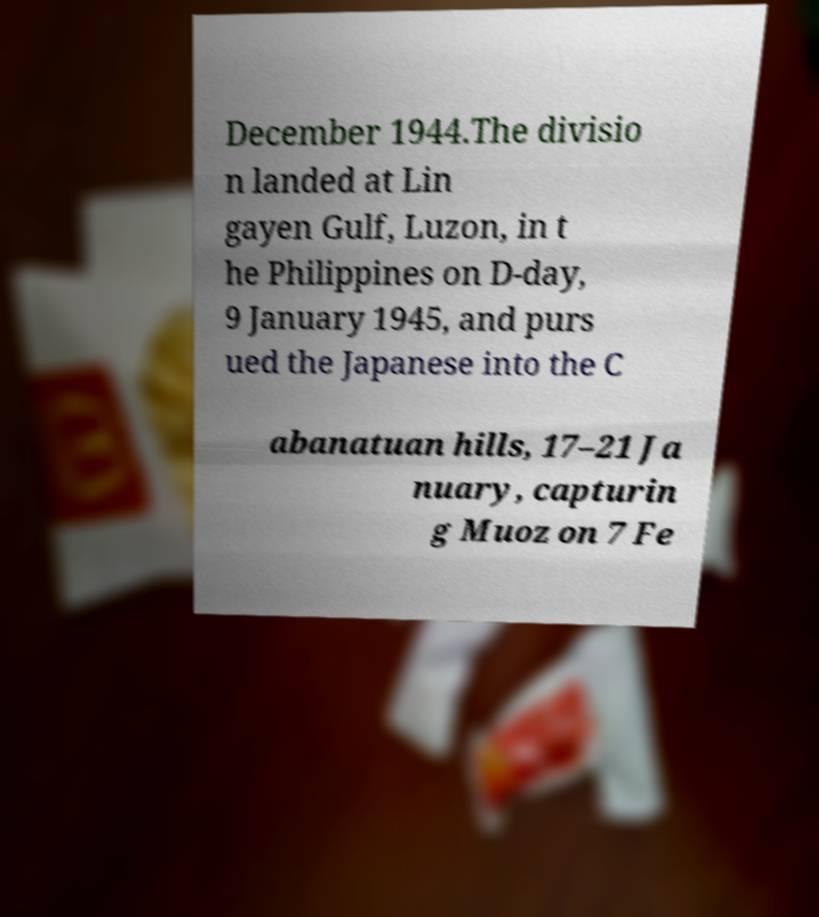For documentation purposes, I need the text within this image transcribed. Could you provide that? December 1944.The divisio n landed at Lin gayen Gulf, Luzon, in t he Philippines on D-day, 9 January 1945, and purs ued the Japanese into the C abanatuan hills, 17–21 Ja nuary, capturin g Muoz on 7 Fe 